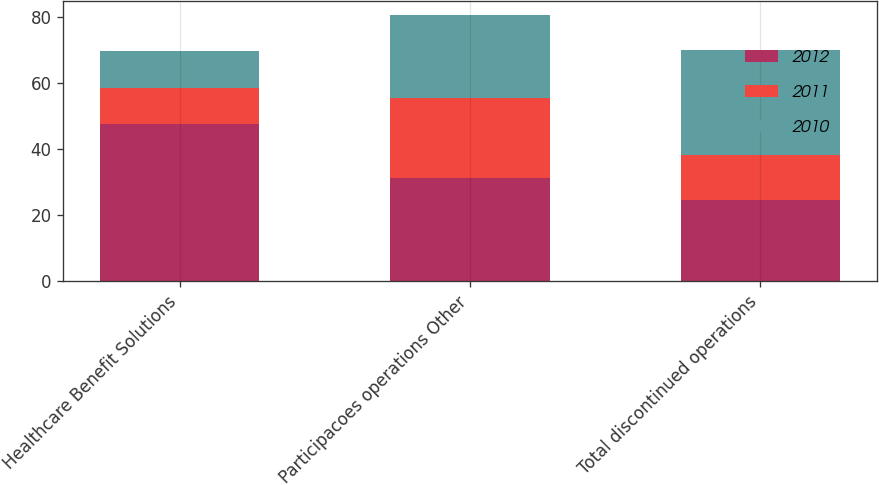<chart> <loc_0><loc_0><loc_500><loc_500><stacked_bar_chart><ecel><fcel>Healthcare Benefit Solutions<fcel>Participacoes operations Other<fcel>Total discontinued operations<nl><fcel>2012<fcel>47.8<fcel>31.4<fcel>24.7<nl><fcel>2011<fcel>10.7<fcel>24.2<fcel>13.5<nl><fcel>2010<fcel>11.3<fcel>25.2<fcel>31.8<nl></chart> 